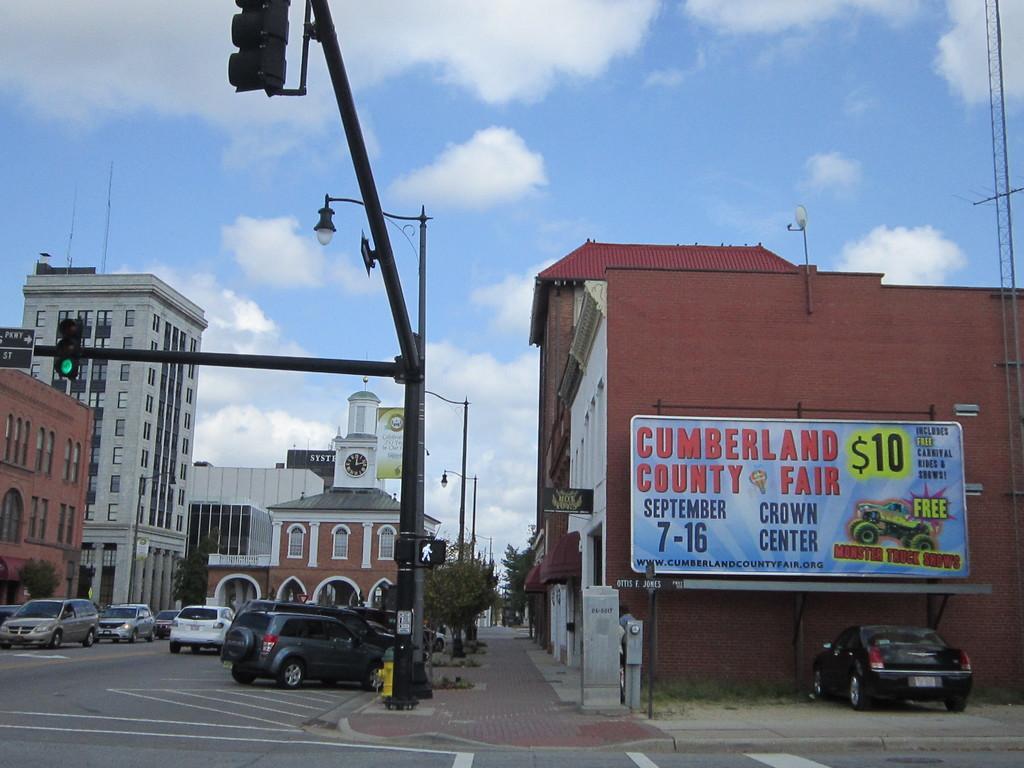Please provide a concise description of this image. In this image I can see the road, number of vehicle on the road, few poles, few traffic signals and few boards. I can see few trees and few buildings on both sides of the road. I can see a huge banner and in the background I can see the sky. 